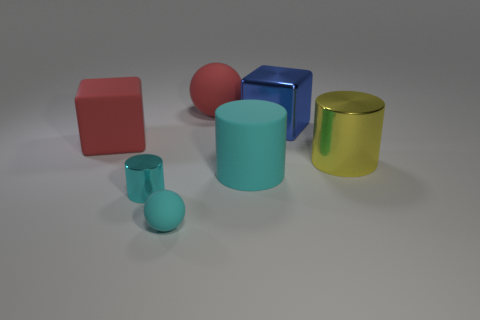Subtract all large metal cylinders. How many cylinders are left? 2 Subtract all blue blocks. How many cyan cylinders are left? 2 Add 2 yellow things. How many objects exist? 9 Subtract all balls. How many objects are left? 5 Subtract 0 purple spheres. How many objects are left? 7 Subtract all yellow balls. Subtract all yellow cylinders. How many balls are left? 2 Subtract all red matte balls. Subtract all large blue shiny things. How many objects are left? 5 Add 6 big blue objects. How many big blue objects are left? 7 Add 4 cyan metal things. How many cyan metal things exist? 5 